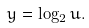Convert formula to latex. <formula><loc_0><loc_0><loc_500><loc_500>y = \log _ { 2 } u .</formula> 